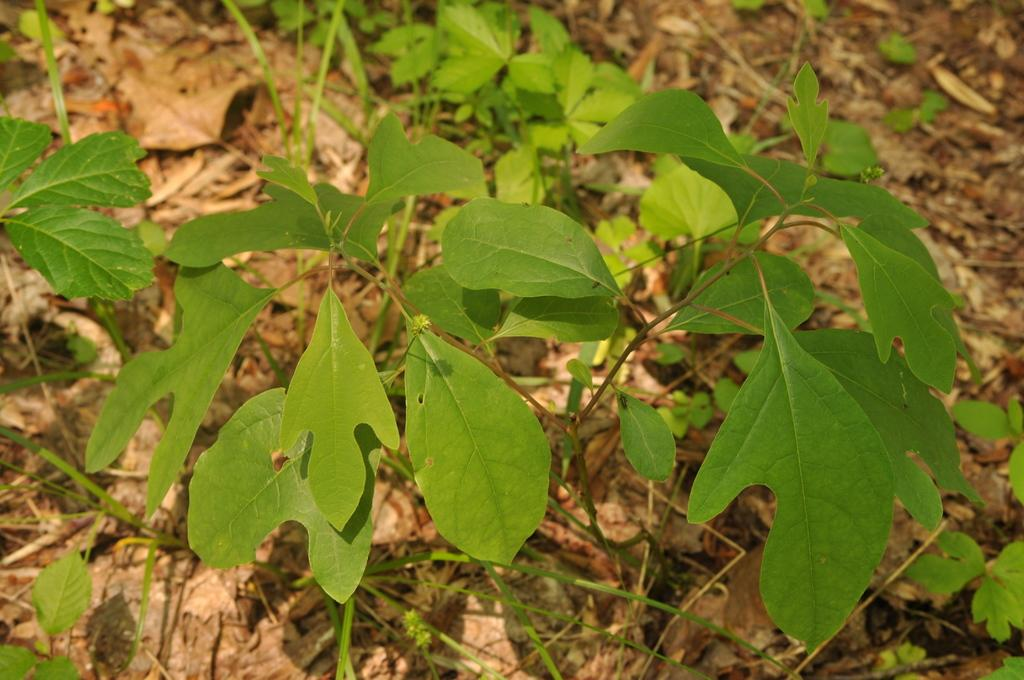What type of living organisms can be seen in the image? Plants can be seen in the image. What is present on the ground in the image? Dried leaves are present on the ground in the image. How many cans of tomatoes are visible in the image? There are no cans of tomatoes present in the image. 